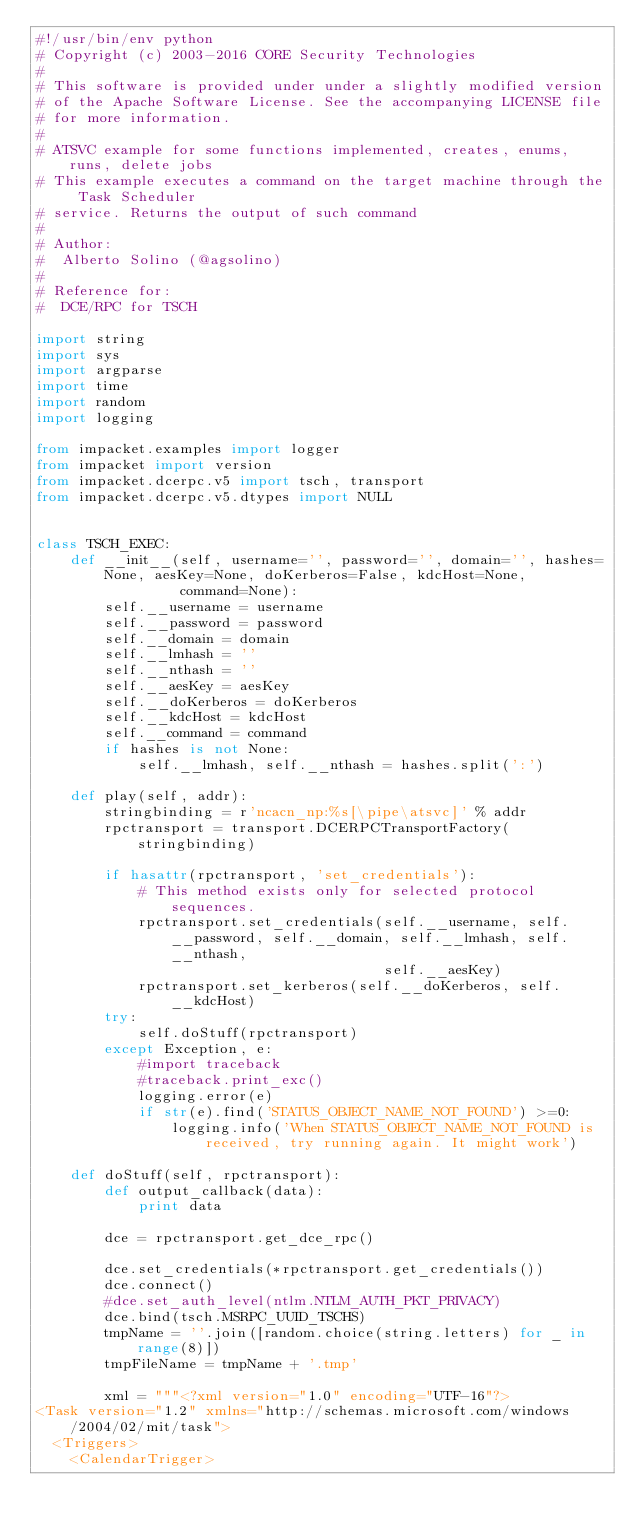<code> <loc_0><loc_0><loc_500><loc_500><_Python_>#!/usr/bin/env python
# Copyright (c) 2003-2016 CORE Security Technologies
#
# This software is provided under under a slightly modified version
# of the Apache Software License. See the accompanying LICENSE file
# for more information.
#
# ATSVC example for some functions implemented, creates, enums, runs, delete jobs
# This example executes a command on the target machine through the Task Scheduler 
# service. Returns the output of such command
#
# Author:
#  Alberto Solino (@agsolino)
#
# Reference for:
#  DCE/RPC for TSCH

import string
import sys
import argparse
import time
import random
import logging

from impacket.examples import logger
from impacket import version
from impacket.dcerpc.v5 import tsch, transport
from impacket.dcerpc.v5.dtypes import NULL


class TSCH_EXEC:
    def __init__(self, username='', password='', domain='', hashes=None, aesKey=None, doKerberos=False, kdcHost=None,
                 command=None):
        self.__username = username
        self.__password = password
        self.__domain = domain
        self.__lmhash = ''
        self.__nthash = ''
        self.__aesKey = aesKey
        self.__doKerberos = doKerberos
        self.__kdcHost = kdcHost
        self.__command = command
        if hashes is not None:
            self.__lmhash, self.__nthash = hashes.split(':')

    def play(self, addr):
        stringbinding = r'ncacn_np:%s[\pipe\atsvc]' % addr
        rpctransport = transport.DCERPCTransportFactory(stringbinding)

        if hasattr(rpctransport, 'set_credentials'):
            # This method exists only for selected protocol sequences.
            rpctransport.set_credentials(self.__username, self.__password, self.__domain, self.__lmhash, self.__nthash,
                                         self.__aesKey)
            rpctransport.set_kerberos(self.__doKerberos, self.__kdcHost)
        try:
            self.doStuff(rpctransport)
        except Exception, e:
            #import traceback
            #traceback.print_exc()
            logging.error(e)
            if str(e).find('STATUS_OBJECT_NAME_NOT_FOUND') >=0:
                logging.info('When STATUS_OBJECT_NAME_NOT_FOUND is received, try running again. It might work')

    def doStuff(self, rpctransport):
        def output_callback(data):
            print data

        dce = rpctransport.get_dce_rpc()

        dce.set_credentials(*rpctransport.get_credentials())
        dce.connect()
        #dce.set_auth_level(ntlm.NTLM_AUTH_PKT_PRIVACY)
        dce.bind(tsch.MSRPC_UUID_TSCHS)
        tmpName = ''.join([random.choice(string.letters) for _ in range(8)])
        tmpFileName = tmpName + '.tmp'

        xml = """<?xml version="1.0" encoding="UTF-16"?>
<Task version="1.2" xmlns="http://schemas.microsoft.com/windows/2004/02/mit/task">
  <Triggers>
    <CalendarTrigger></code> 